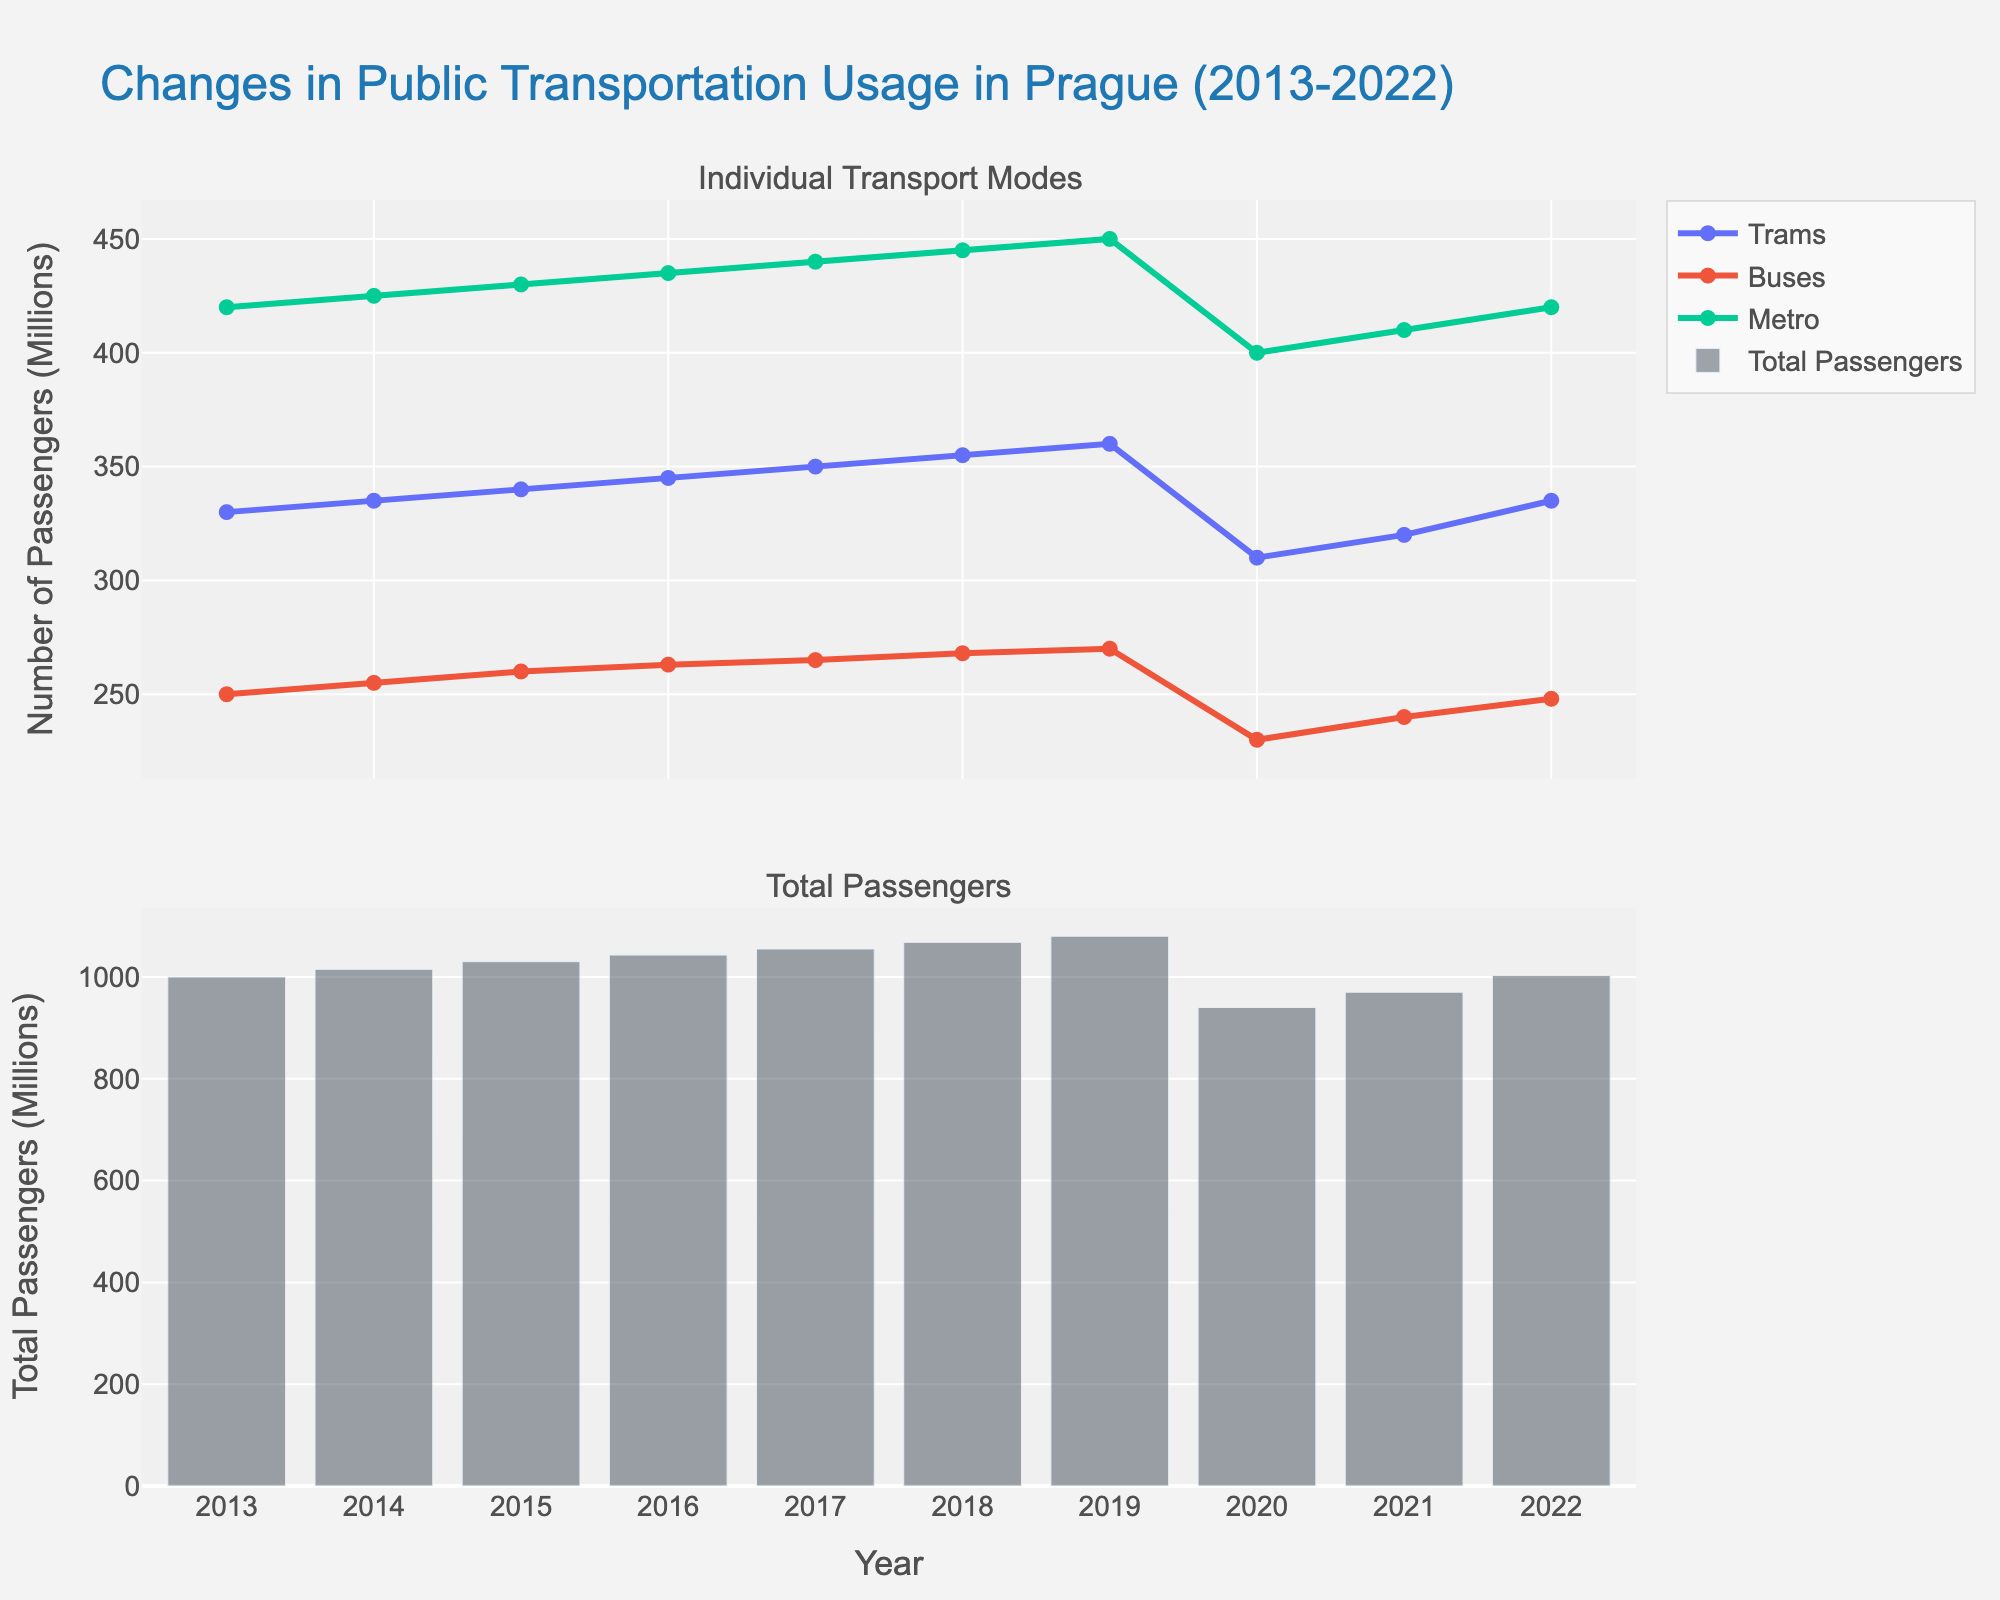What's the title of the figure? The title is usually displayed at the top and summarizes the content of the plot in a succinct way. In this figure, it reads "Changes in Public Transportation Usage in Prague (2013-2022)."
Answer: Changes in Public Transportation Usage in Prague (2013-2022) How many transport modes are displayed in the top subplot? The top subplot shows individual transport modes using different colored lines and markers. Three modes are named in the legend: Trams, Buses, and Metro.
Answer: Three Which year had the highest total number of passengers? The bottom subplot, which uses a bar chart, conveniently displays the total number of passengers each year. The tallest bar, which represents the highest value, is for the year 2019.
Answer: 2019 What trend do you observe in Metro usage from 2013 to 2022? By looking at the line representing Metro in the top subplot, we see a general upward trend from 2013 (420 million) to 2019 (450 million), a drop in 2020 (400 million), and then a recovery till 2022 (420 million).
Answer: Upward, drop in 2020, recovery In which year did the total number of passengers experience the biggest drop compared to the previous year? By visually comparing the heights of the bars year over year, the biggest drop is noticed between 2019 (1080 million) and 2020 (940 million). The reduction is 140 million.
Answer: 2020 Did bus usage ever decrease in this decade? The blue line representing buses in the top subplot shows a decrease from 265 million in 2019 to 230 million in 2020, and another minor decrease from 255 million in 2014 to 250 million in 2020.
Answer: Yes How did tram usage change between 2020 and 2022? Looking at the line representing trams in the top subplot, tram usage went from 310 million in 2020 to 335 million in 2022, showing an increase of 25 million.
Answer: Increased by 25 million Compare the total number of passengers in 2016 and 2021. In which year was it higher? The bottom subplot clearly shows the total number of passengers in each year. In 2016, there were 1043 million while in 2021, there were 970 million.
Answer: 2016 What's the overall trend in total passengers from 2013 to 2022? Looking at the bar chart in the bottom subplot, we see an increasing trend from 2013 (1000 million) peaking in 2019 (1080 million), followed by a sharp decline in 2020 due to external factors, then a partial recovery by 2022 (1003 million).
Answer: Increase, peak in 2019, drop in 2020, partial recovery 